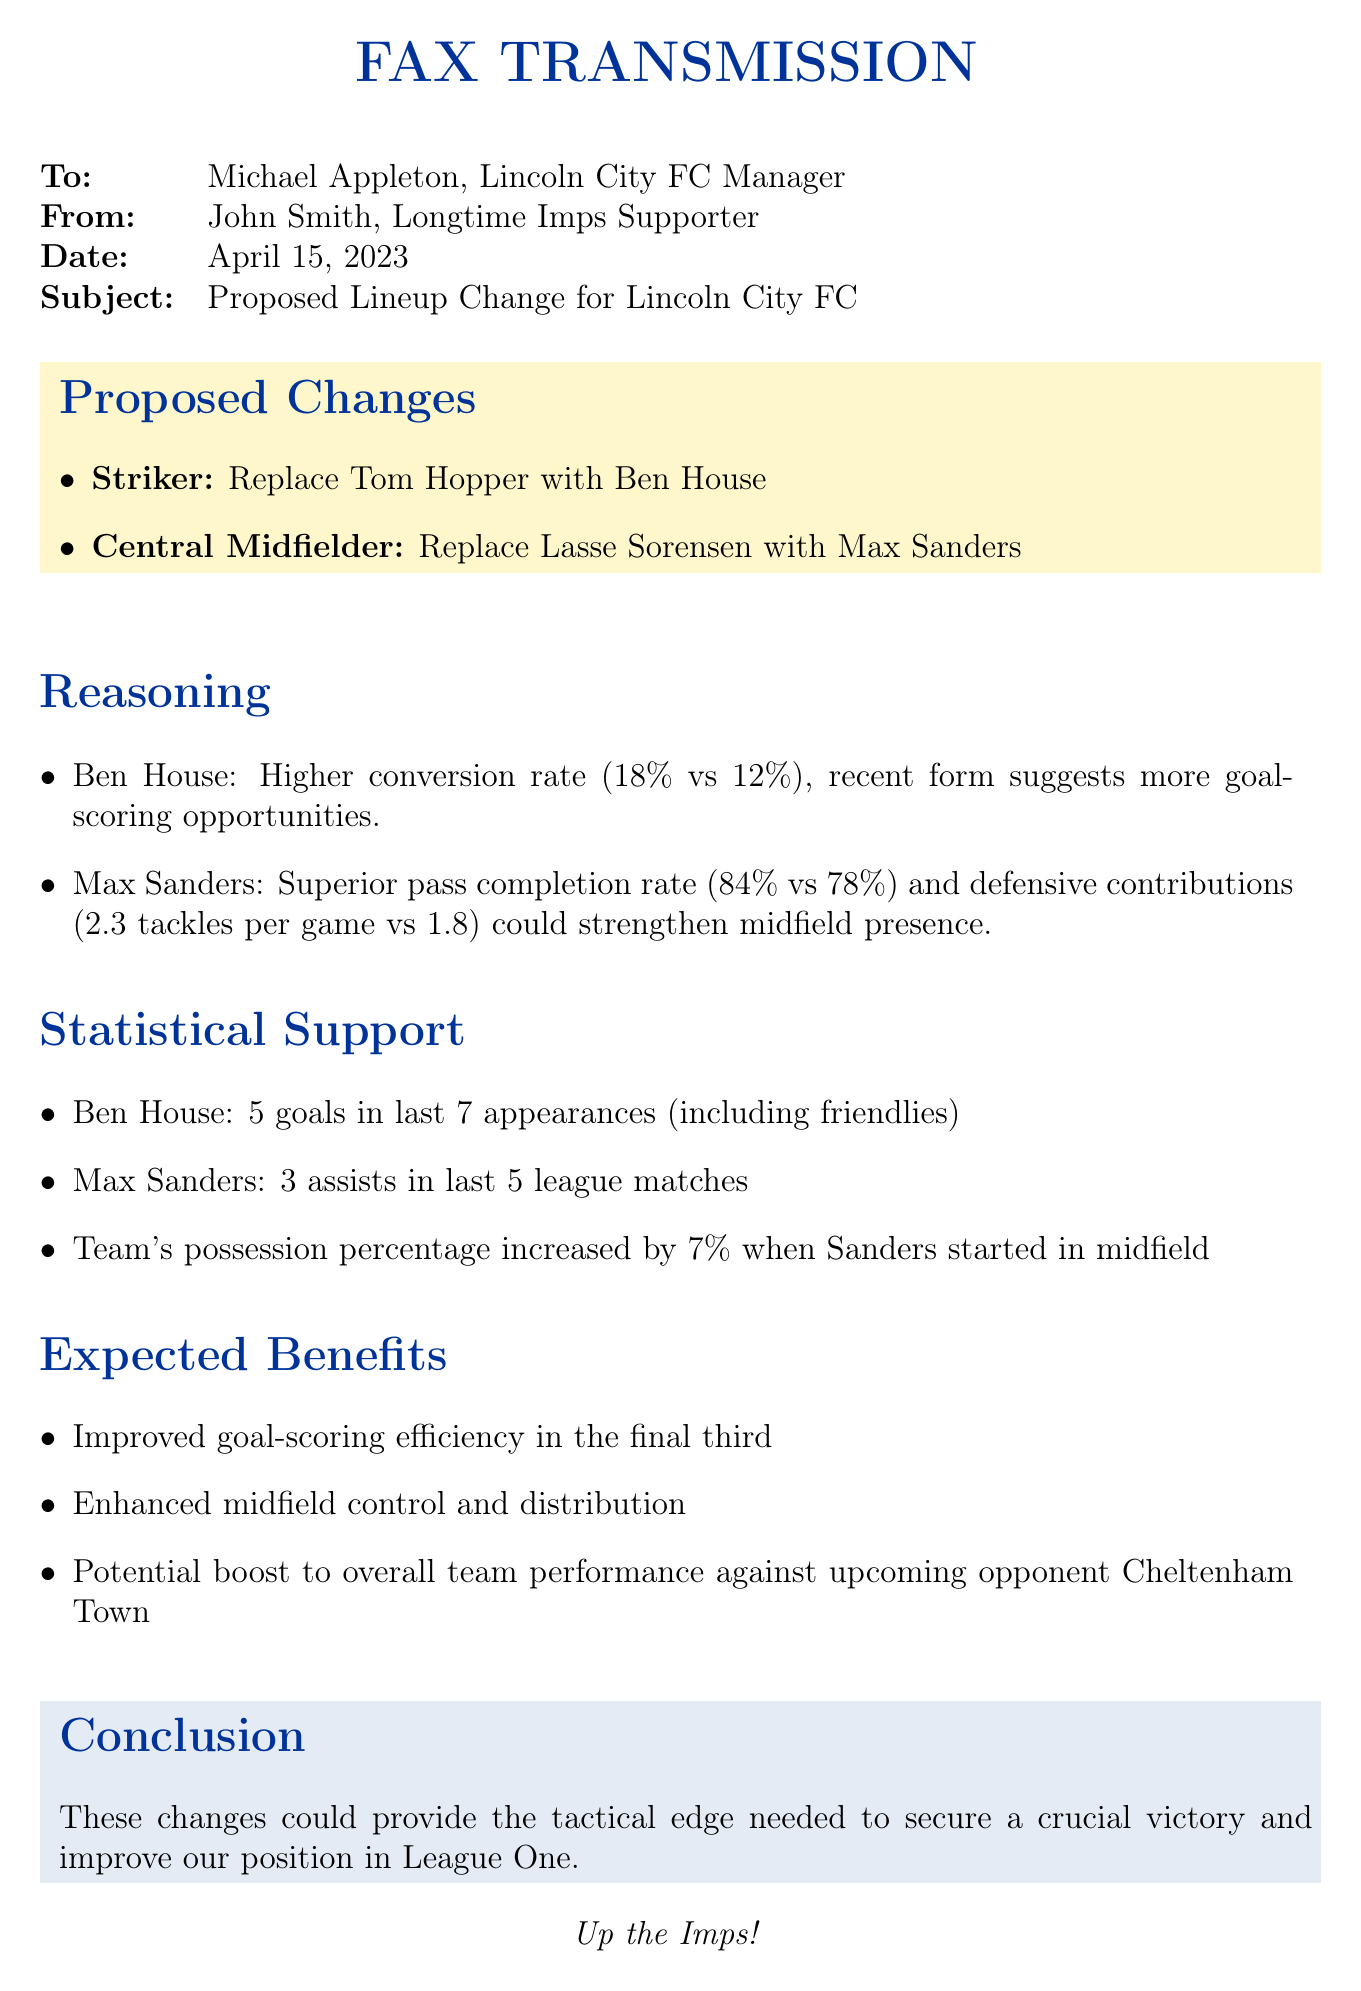What is the subject of the fax? The subject of the fax is stated clearly, detailing the proposed changes in the team lineup.
Answer: Proposed Lineup Change for Lincoln City FC Who is the sender of the fax? The sender's name is provided in the document, reflecting the communication source.
Answer: John Smith What date was the fax sent? The specific date of the fax transmission is listed in the header section.
Answer: April 15, 2023 Who is being replaced as a striker? The document specifies a player who is suggested to be replaced in the lineup.
Answer: Tom Hopper What is Ben House's conversion rate? The fax includes a statistic about Ben House's performance related to scoring.
Answer: 18% How many goals has Ben House scored in the last 7 appearances? The stat mentioned focuses on the recent scoring performance of Ben House.
Answer: 5 goals What is Max Sanders' pass completion rate? The document presents a statistic about Max Sanders' effectiveness in passing.
Answer: 84% What is one expected benefit of the proposed changes? The fax lists potential benefits that the changes to the lineup may bring to the team's performance.
Answer: Improved goal-scoring efficiency in the final third What percentage did team possession increase when Sanders started? The document highlights a measurable impact related to team possession when a specific player is in the lineup.
Answer: 7% What conclusion is drawn about the proposed changes? The closing part of the fax summarizes the overall assessment of the effect of the changes.
Answer: Tactical edge needed to secure a crucial victory 